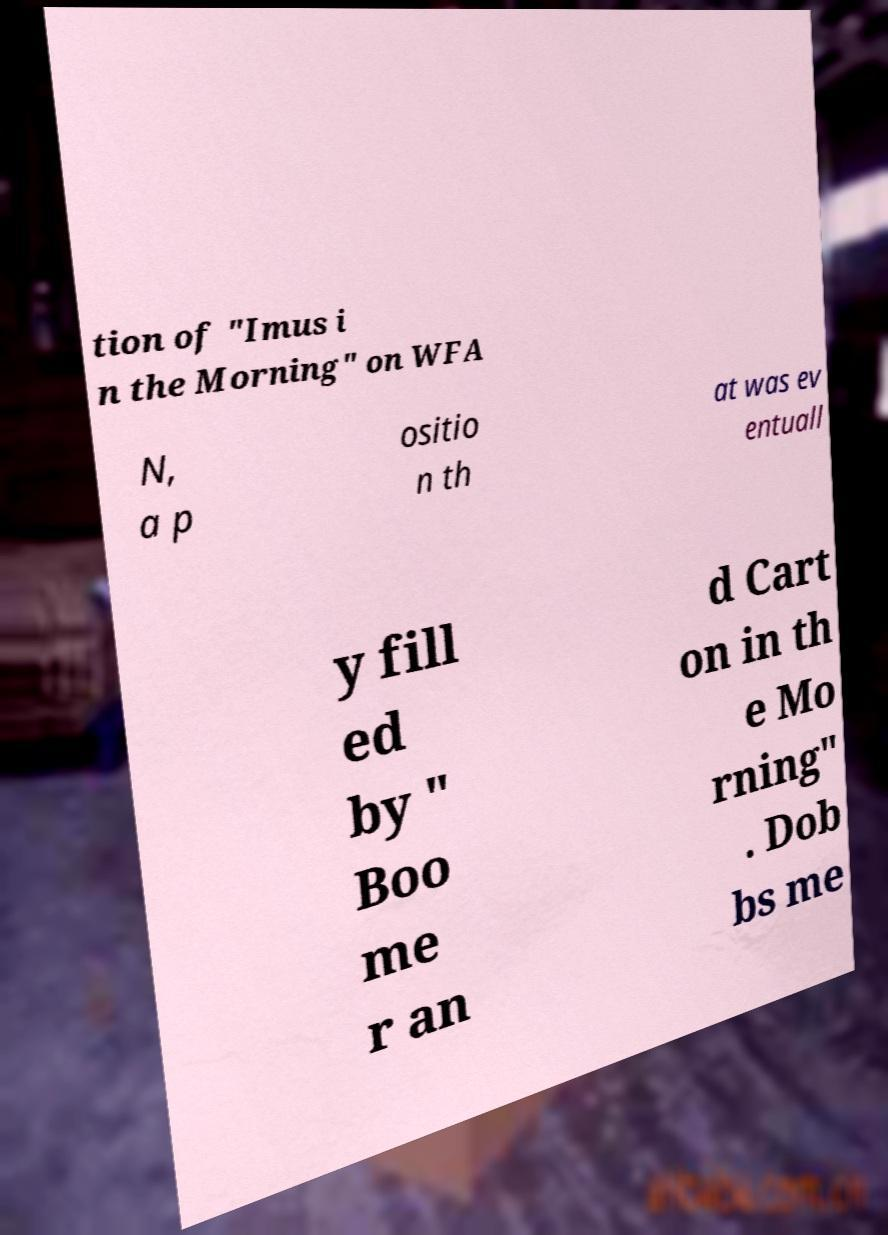Please identify and transcribe the text found in this image. tion of "Imus i n the Morning" on WFA N, a p ositio n th at was ev entuall y fill ed by " Boo me r an d Cart on in th e Mo rning" . Dob bs me 